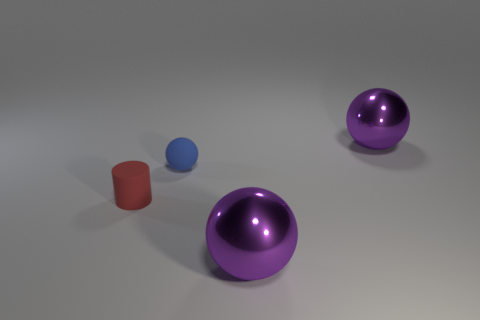Are there any other rubber balls of the same color as the tiny rubber ball?
Make the answer very short. No. What number of tiny things are either yellow metal things or blue rubber things?
Offer a terse response. 1. Are the small object to the left of the blue rubber sphere and the tiny blue ball made of the same material?
Ensure brevity in your answer.  Yes. What shape is the purple thing that is right of the large purple metallic thing left of the big purple metallic object that is behind the red cylinder?
Ensure brevity in your answer.  Sphere. What number of blue things are either rubber balls or tiny metallic cubes?
Keep it short and to the point. 1. Are there an equal number of blue rubber objects that are right of the blue matte thing and metal objects in front of the small rubber cylinder?
Offer a terse response. No. Does the tiny rubber thing that is to the right of the red matte thing have the same shape as the big purple object that is in front of the small rubber ball?
Offer a terse response. Yes. Is there any other thing that is the same shape as the small blue matte object?
Make the answer very short. Yes. What shape is the other small object that is the same material as the tiny blue object?
Your response must be concise. Cylinder. Are there the same number of purple metal objects to the left of the tiny blue rubber ball and tiny blue balls?
Provide a succinct answer. No. 